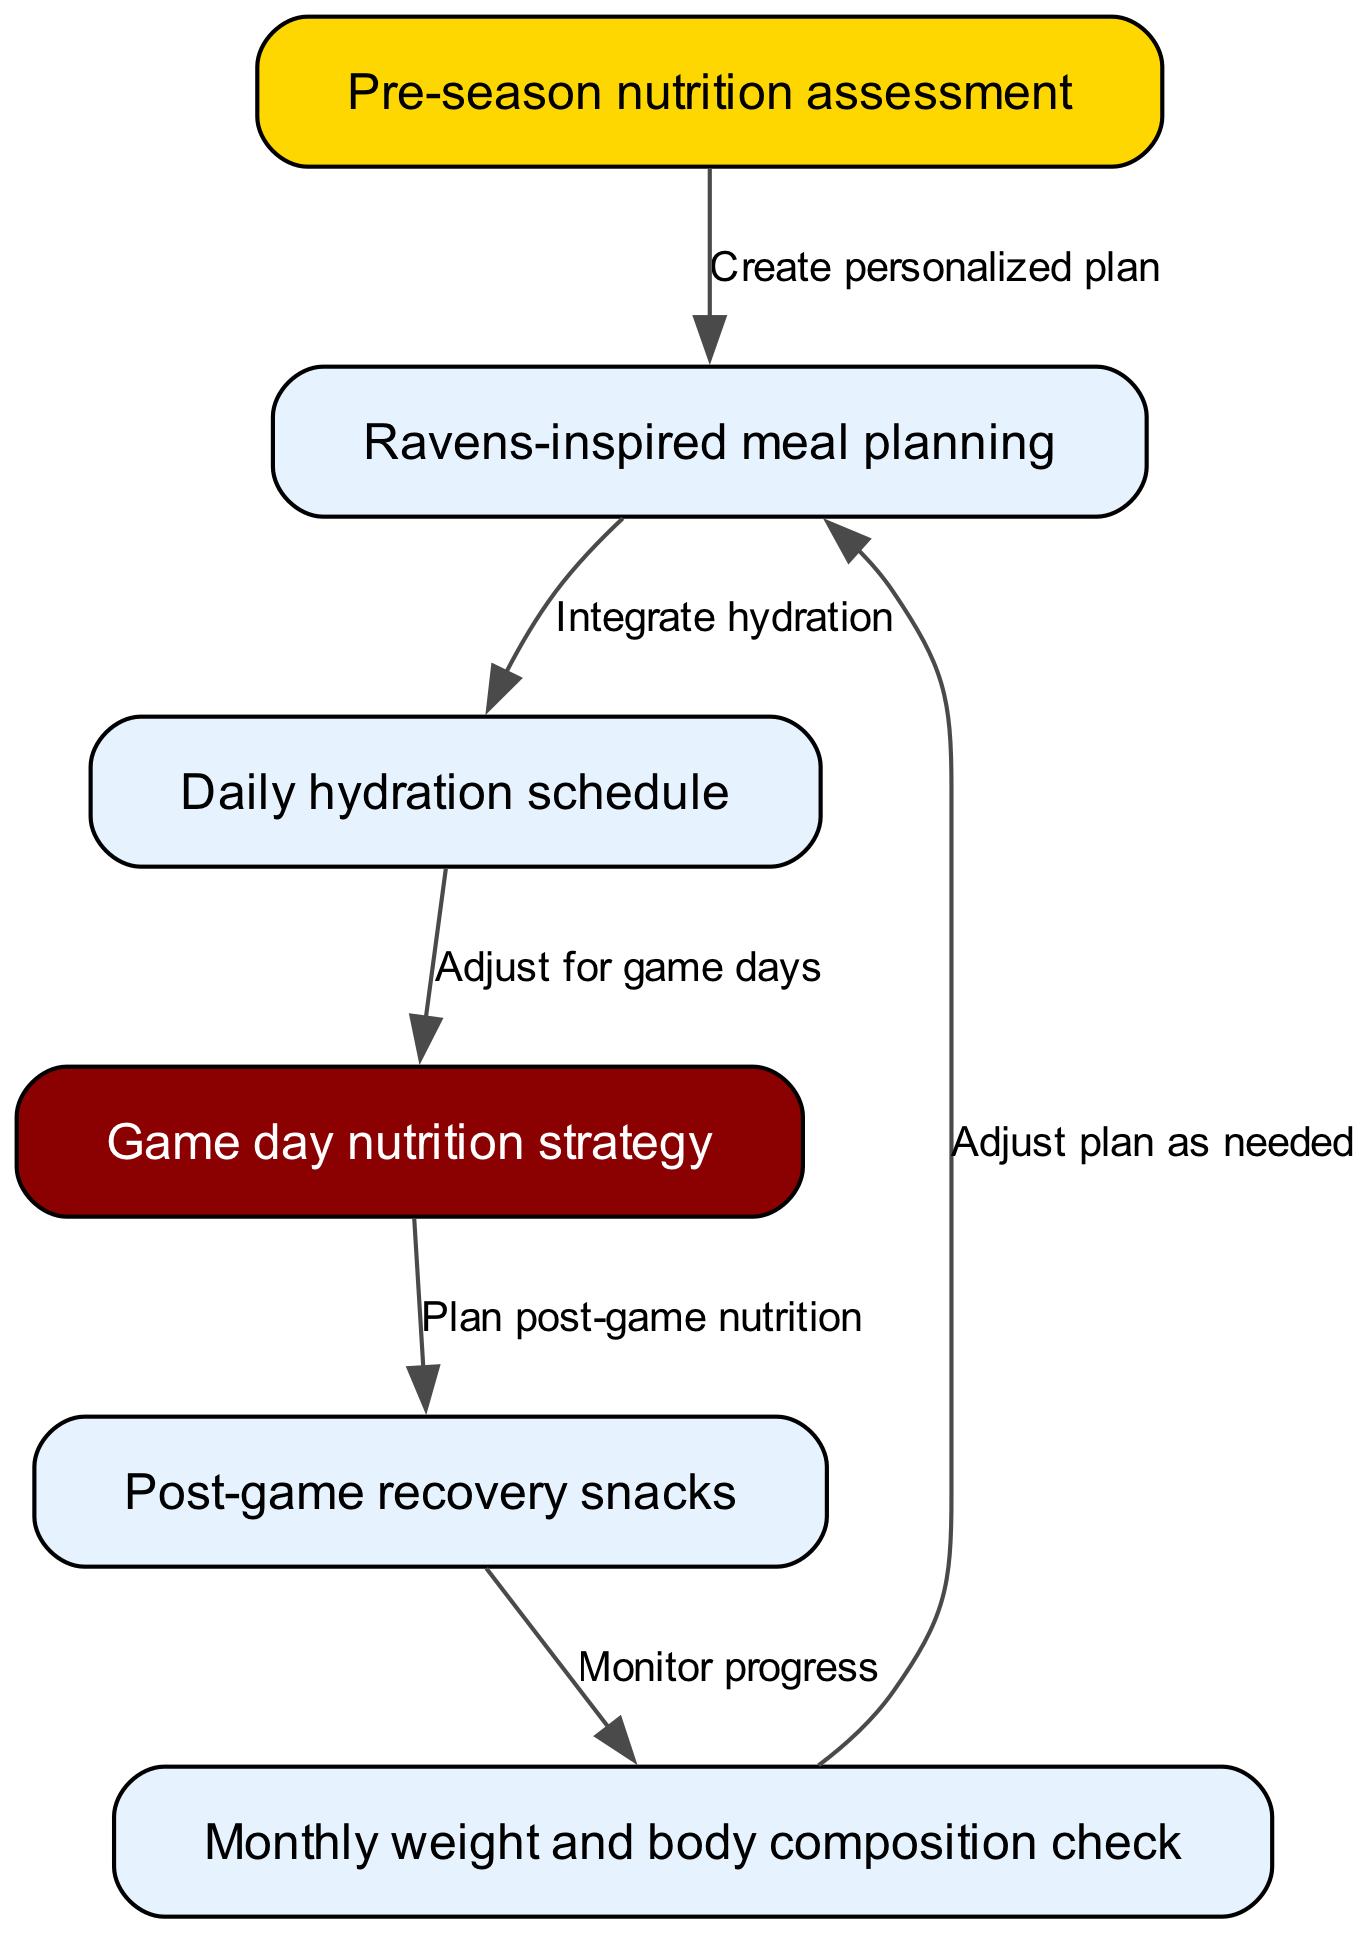What is the first step in the pathway? The first step in the pathway is the "Pre-season nutrition assessment" (node 1), which is represented at the top of the diagram and initiates the process.
Answer: Pre-season nutrition assessment How many nodes are there in the diagram? By counting the nodes listed in the data, there are six distinct nodes related to the nutrition and hydration management plan.
Answer: 6 What connects the "Ravens-inspired meal planning" to the "Daily hydration schedule"? The connection from "Ravens-inspired meal planning" (node 2) to "Daily hydration schedule" (node 3) is represented by the edge labeled "Integrate hydration", indicating the integration of hydration into the meal plan.
Answer: Integrate hydration What is planned immediately after the "Game day nutrition strategy"? The process continues with "Post-game recovery snacks" following the "Game day nutrition strategy", as indicated by the edge connecting node 4 to node 5.
Answer: Post-game recovery snacks What action is taken after the "Post-game recovery snacks" step? Following "Post-game recovery snacks", the next step is to perform a "Monthly weight and body composition check" as indicated by the connection from node 5 to node 6.
Answer: Monthly weight and body composition check What feedback loop is present in the diagram? The diagram includes a feedback loop from "Monthly weight and body composition check" (node 6) back to "Ravens-inspired meal planning" (node 2), indicating that adjustments to the meal plan are made as necessary based on progress monitoring.
Answer: Adjust plan as needed Which two nodes are directly connected by an edge indicating a strategy for game days? The "Daily hydration schedule" (node 3) connects to "Game day nutrition strategy" (node 4), indicating adjustments specifically for game days.
Answer: Daily hydration schedule and Game day nutrition strategy What is the significance of the color of the "Pre-season nutrition assessment" node? The color of the "Pre-season nutrition assessment" node is gold, which signifies its importance as the first step in creating a personalized nutrition and hydration plan for the season.
Answer: Gold 